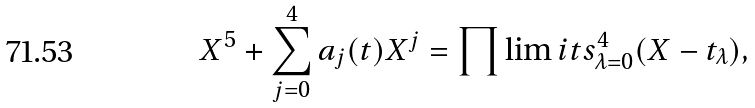<formula> <loc_0><loc_0><loc_500><loc_500>X ^ { 5 } + \sum _ { j = 0 } ^ { 4 } a _ { j } ( t ) X ^ { j } = \prod \lim i t s _ { \lambda = 0 } ^ { 4 } ( X - t _ { \lambda } ) ,</formula> 